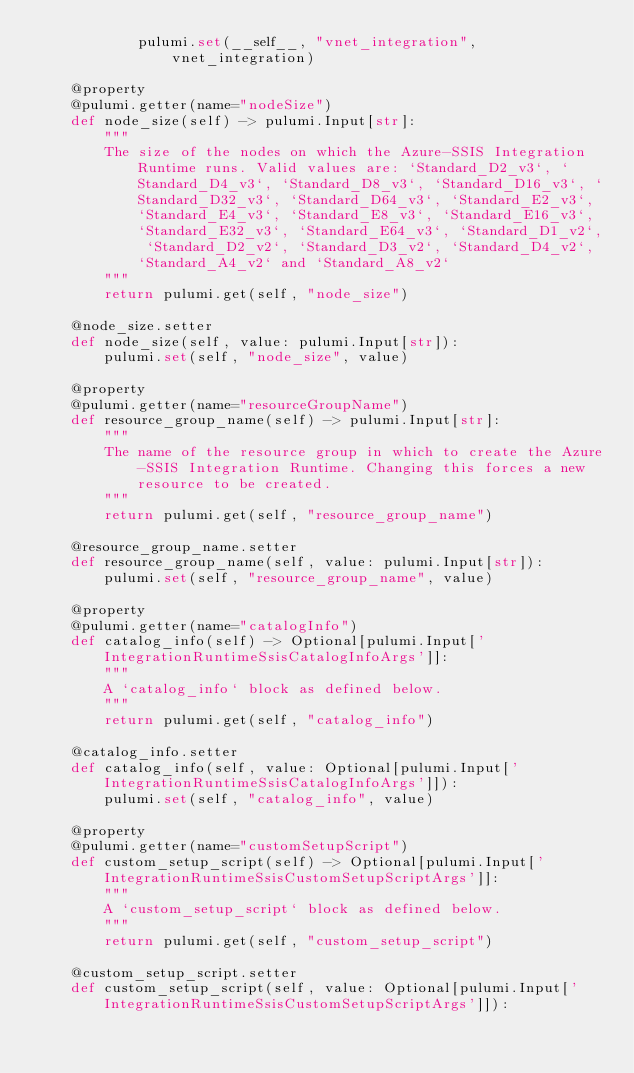<code> <loc_0><loc_0><loc_500><loc_500><_Python_>            pulumi.set(__self__, "vnet_integration", vnet_integration)

    @property
    @pulumi.getter(name="nodeSize")
    def node_size(self) -> pulumi.Input[str]:
        """
        The size of the nodes on which the Azure-SSIS Integration Runtime runs. Valid values are: `Standard_D2_v3`, `Standard_D4_v3`, `Standard_D8_v3`, `Standard_D16_v3`, `Standard_D32_v3`, `Standard_D64_v3`, `Standard_E2_v3`, `Standard_E4_v3`, `Standard_E8_v3`, `Standard_E16_v3`, `Standard_E32_v3`, `Standard_E64_v3`, `Standard_D1_v2`, `Standard_D2_v2`, `Standard_D3_v2`, `Standard_D4_v2`, `Standard_A4_v2` and `Standard_A8_v2`
        """
        return pulumi.get(self, "node_size")

    @node_size.setter
    def node_size(self, value: pulumi.Input[str]):
        pulumi.set(self, "node_size", value)

    @property
    @pulumi.getter(name="resourceGroupName")
    def resource_group_name(self) -> pulumi.Input[str]:
        """
        The name of the resource group in which to create the Azure-SSIS Integration Runtime. Changing this forces a new resource to be created.
        """
        return pulumi.get(self, "resource_group_name")

    @resource_group_name.setter
    def resource_group_name(self, value: pulumi.Input[str]):
        pulumi.set(self, "resource_group_name", value)

    @property
    @pulumi.getter(name="catalogInfo")
    def catalog_info(self) -> Optional[pulumi.Input['IntegrationRuntimeSsisCatalogInfoArgs']]:
        """
        A `catalog_info` block as defined below.
        """
        return pulumi.get(self, "catalog_info")

    @catalog_info.setter
    def catalog_info(self, value: Optional[pulumi.Input['IntegrationRuntimeSsisCatalogInfoArgs']]):
        pulumi.set(self, "catalog_info", value)

    @property
    @pulumi.getter(name="customSetupScript")
    def custom_setup_script(self) -> Optional[pulumi.Input['IntegrationRuntimeSsisCustomSetupScriptArgs']]:
        """
        A `custom_setup_script` block as defined below.
        """
        return pulumi.get(self, "custom_setup_script")

    @custom_setup_script.setter
    def custom_setup_script(self, value: Optional[pulumi.Input['IntegrationRuntimeSsisCustomSetupScriptArgs']]):</code> 